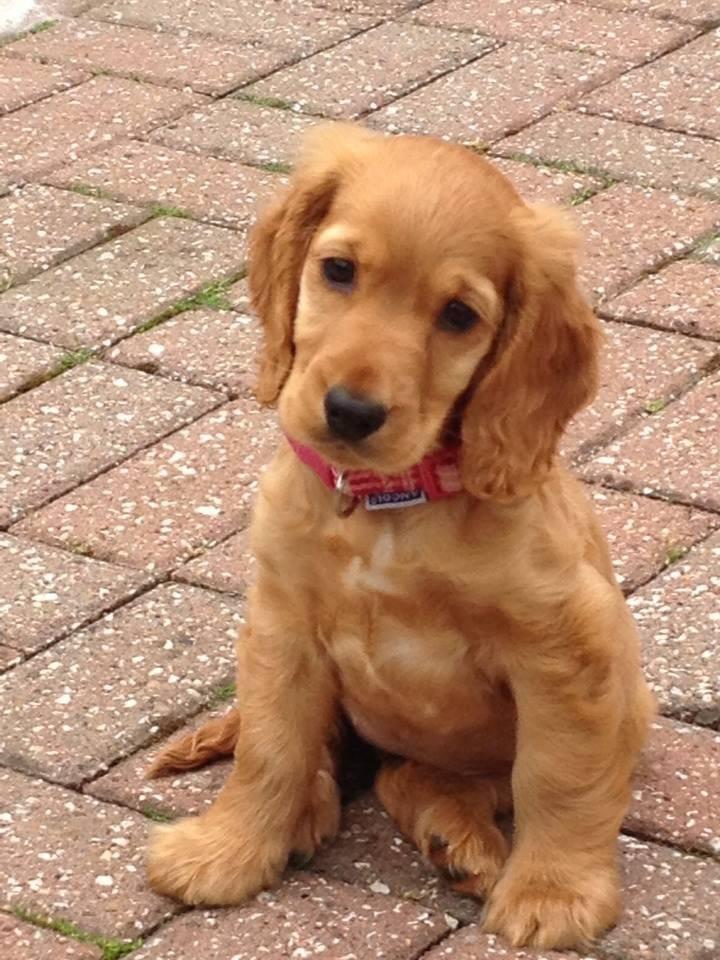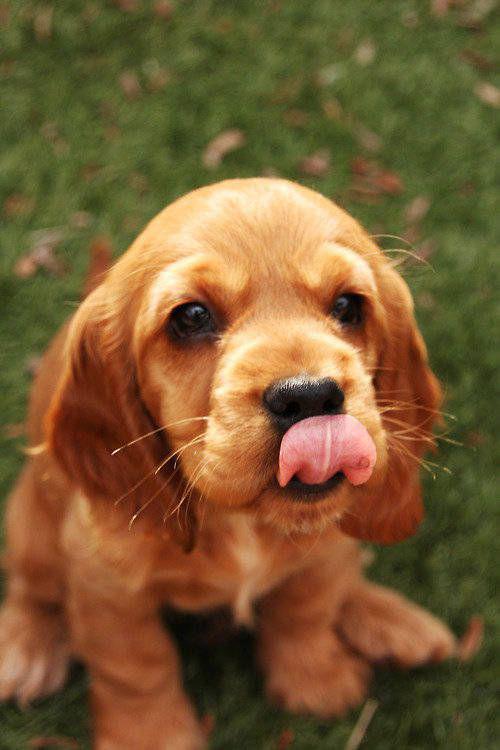The first image is the image on the left, the second image is the image on the right. Assess this claim about the two images: "The animal in one of the images is on a white background". Correct or not? Answer yes or no. No. The first image is the image on the left, the second image is the image on the right. Considering the images on both sides, is "One of the dogs is wearing a dog collar." valid? Answer yes or no. Yes. 